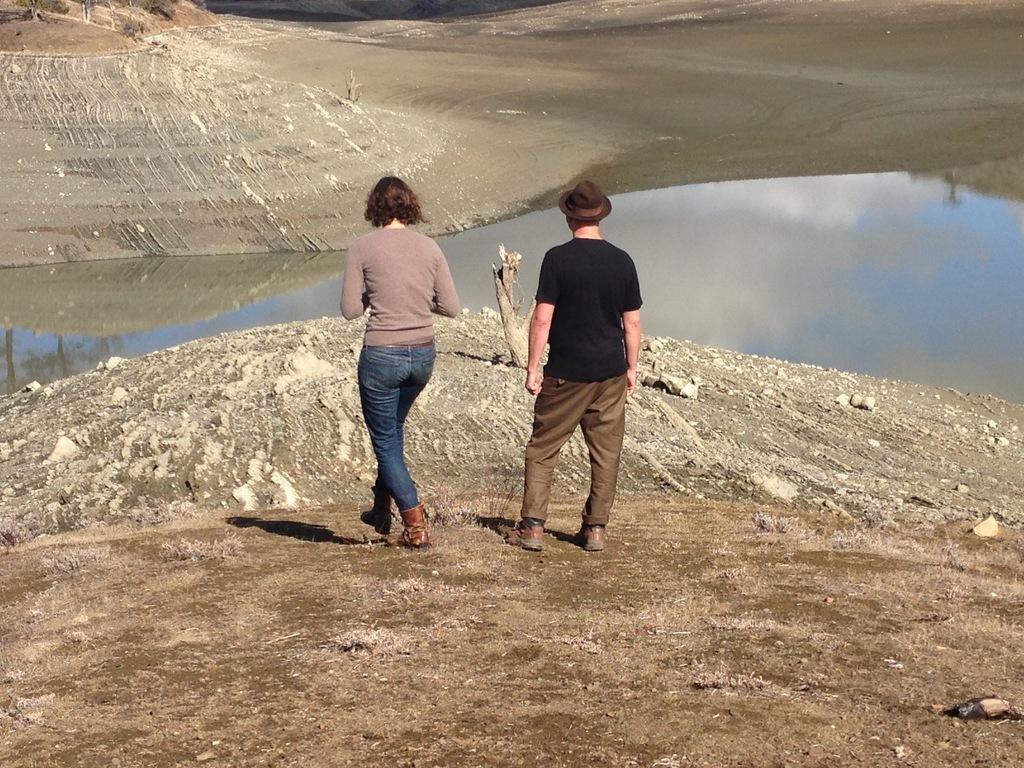Could you give a brief overview of what you see in this image? In this image there are two people standing at the bank of lake beside that there is some mud. 